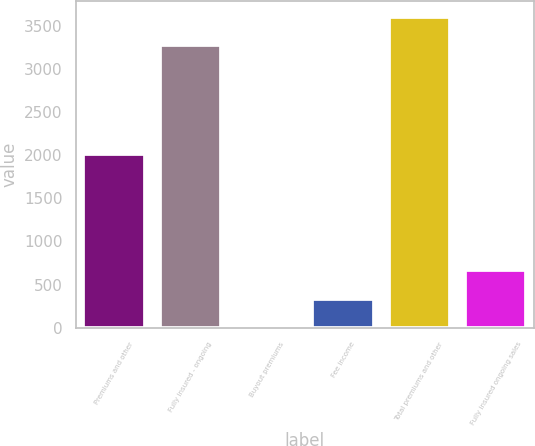Convert chart to OTSL. <chart><loc_0><loc_0><loc_500><loc_500><bar_chart><fcel>Premiums and other<fcel>Fully insured - ongoing<fcel>Buyout premiums<fcel>Fee income<fcel>Total premiums and other<fcel>Fully insured ongoing sales<nl><fcel>2013<fcel>3272<fcel>1<fcel>333.9<fcel>3604.9<fcel>666.8<nl></chart> 